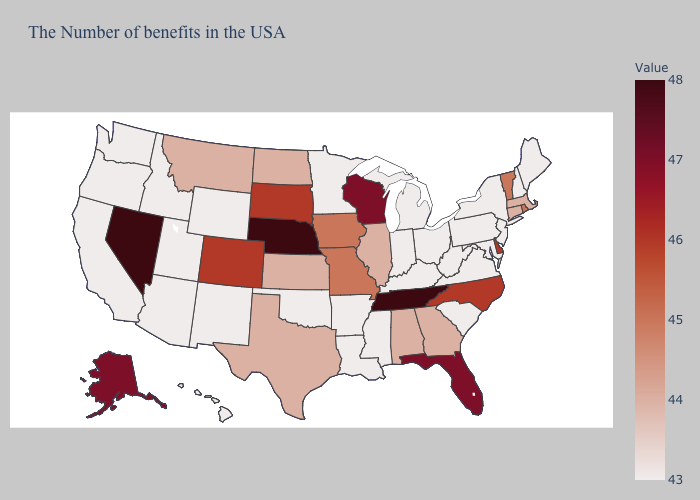Which states have the lowest value in the South?
Write a very short answer. Maryland, Virginia, South Carolina, West Virginia, Kentucky, Mississippi, Louisiana, Arkansas, Oklahoma. Does South Dakota have the highest value in the USA?
Write a very short answer. No. Does the map have missing data?
Keep it brief. No. Does the map have missing data?
Short answer required. No. Does Alabama have the lowest value in the South?
Keep it brief. No. Does Nebraska have the highest value in the MidWest?
Quick response, please. Yes. Does Massachusetts have a lower value than Alaska?
Quick response, please. Yes. 